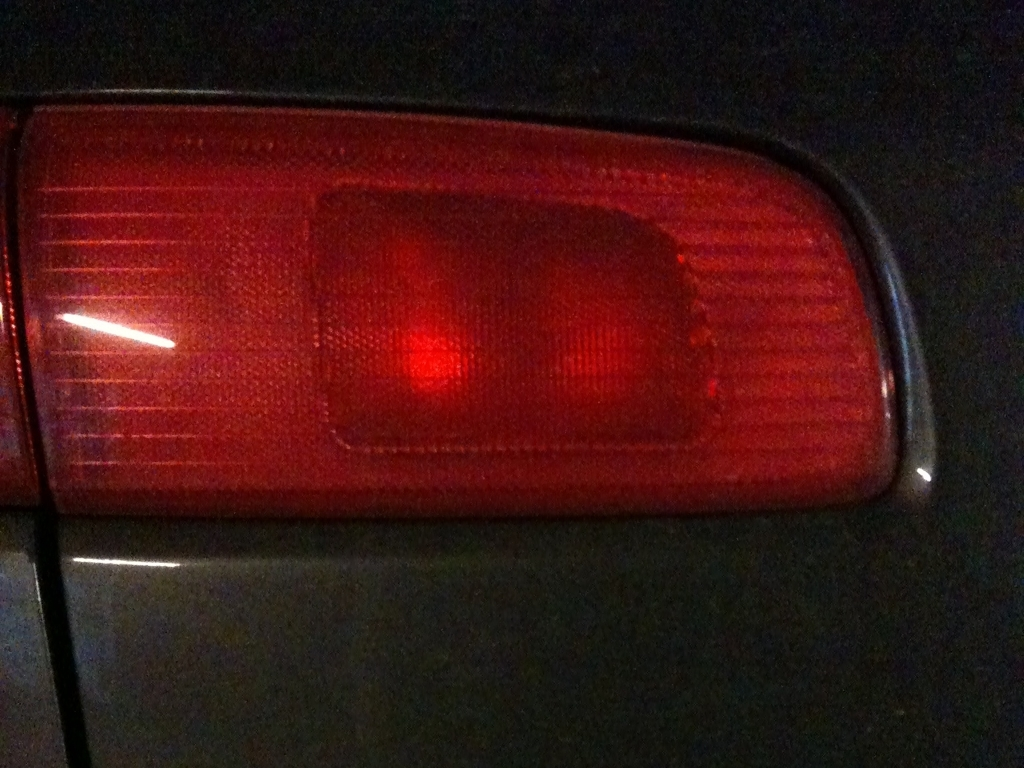What kind of vehicle do you think this tail light belongs to? Based on the design of the tail light, it appears to be relatively simple and functional, potentially indicating that it belongs to an older model car or a more budget-friendly vehicle where extravagant design isn't prioritized. 